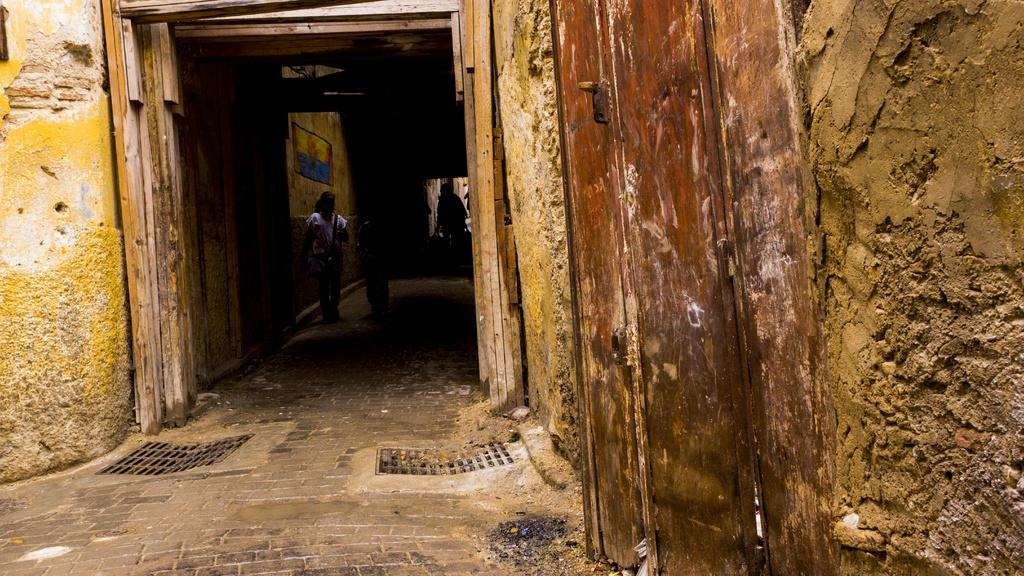What is happening in the image? There are people standing in the image. Can you describe the lighting or atmosphere in the image? There is a sense of darkness in the image. Where is the rabbit hiding in the image? There is no rabbit present in the image. What type of mountain can be seen in the background of the image? There is no mountain visible in the image; it only shows people standing in a dark setting. 